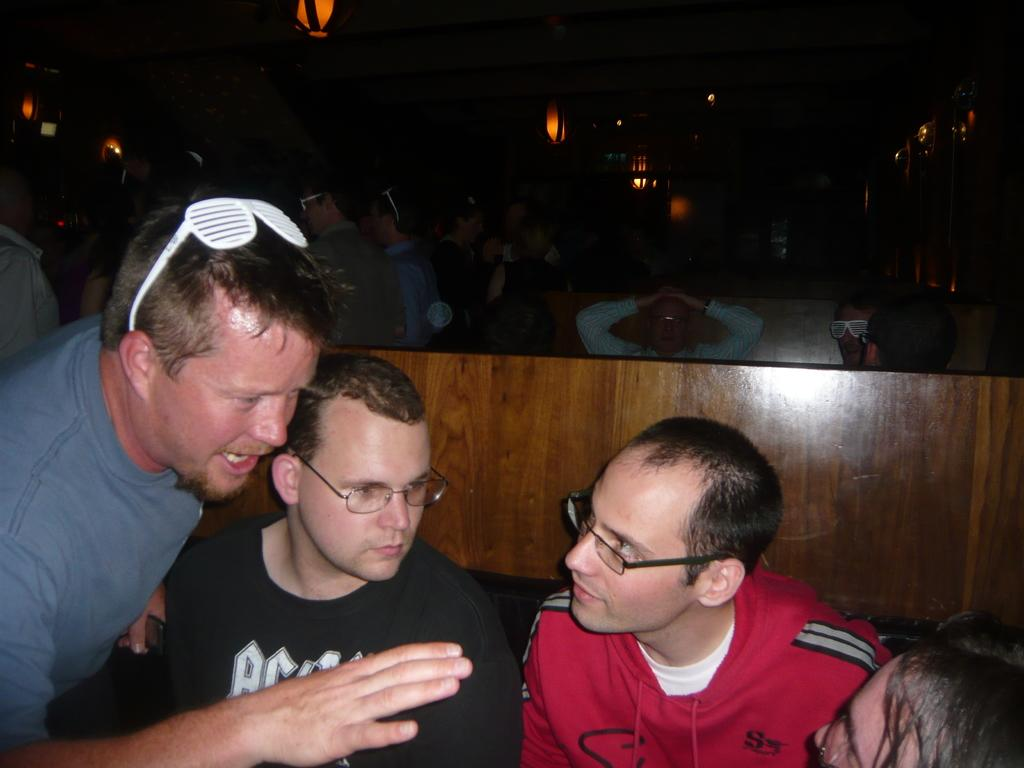How many people are in the image? There is a group of people in the image. Can you describe the clothing of one person in the group? One person in the group is wearing a white and red color dress. What can be seen in the background of the image? There are lights visible in the background of the image. What type of animal is sitting on the person's knee in the image? There is no animal present in the image, and no one is sitting on anyone's knee. Is there a mailbox visible in the image? There is no mailbox present in the image. 